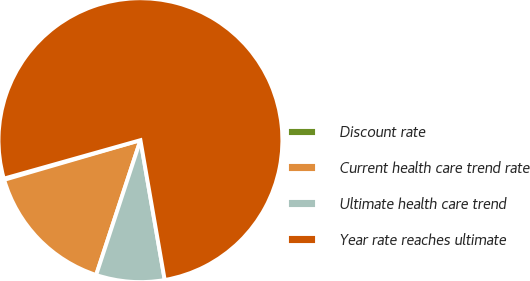Convert chart to OTSL. <chart><loc_0><loc_0><loc_500><loc_500><pie_chart><fcel>Discount rate<fcel>Current health care trend rate<fcel>Ultimate health care trend<fcel>Year rate reaches ultimate<nl><fcel>0.14%<fcel>15.44%<fcel>7.79%<fcel>76.63%<nl></chart> 